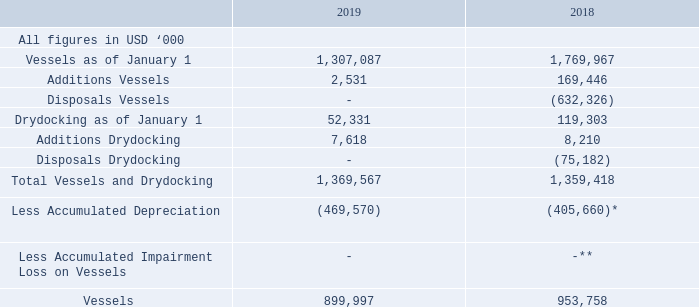4. VESSELS
Vessels consists of the carrying value of 23 vessels for the year ended December 31, 2019 and December 31, 2018, respectively. Vessels includes capitalized drydocking costs.
Depreciation is calculated based on cost less estimated residual value of $8.0 million per vessel over the estimated useful life of the vessel using the straight-line method. The estimated useful life of a vessel is 25 years from the date the vessel is delivered from the shipyard.
*Depreciation charges of $497.0 million related to vessels disposed of in 2018 is excluded
** Impairment charges of $2.2 million and $110.5 million related to vessels disposed of in 2018 is excluded
The Company has taken three vessels through periodical maintenance surveys in 2019 and further two vessels were in drydock for periodical maintenance as at December 31, 2019.
Impairment Loss on Vessels
The Company has not recorded any impairment loss on vessels for the year ended December 31, 2019. The Company recorded an impairment loss of $2.2 million and $110.5 million for the years ended December 31, 2018 and December 31, 2017, respectively.
The Company reviewed its assets for impairment on an asset by asset basis. In determining whether the assets are recoverable, the Company compared the estimate of the undiscounted cash flows expected to be generated by the assets to its carrying value. As of December 31, 2019, it was determined that the sum of the undiscounted cash flows for each vessel exceeded its carrying value and no impairment was recorded.
In developing estimates of future undiscounted cash flows, we made assumptions and estimates based on historical trends as well as future expectations. The most important assumption in determining undiscounted cash flows are the estimated freight rates. Freight rates are volatile and the analysis is based on market rates obtained from third parties, in combination with historical achieved rates by the Company.
What are the respective values excluded from the Accumulated Impairment Loss on Vessels? Impairment charges of $2.2 million, $110.5 million related to vessels disposed of in 2018. What is excluded from the accumulated depreciation of vessels in 2018? Depreciation charges of $497.0 million related to vessels disposed of in 2018. What are the respective values of vessels as of January 1, 2018 and 2019? 1,769,967, 1,307,087. What is the percentage change in the value of vessels between January 1, 2018 and 2019?
Answer scale should be: percent. (1,307,087 - 1,769,967)/1,769,967 
Answer: -26.15. What is the average value of additional vessels added in 2018 and 2019?
Answer scale should be: thousand. (169,446 + 2,531)/2 
Answer: 85988.5. What is the percentage change in the value of vessel additions between 2018 and 2019?
Answer scale should be: percent. (2,531 - 169,446)/169,446 
Answer: -98.51. 